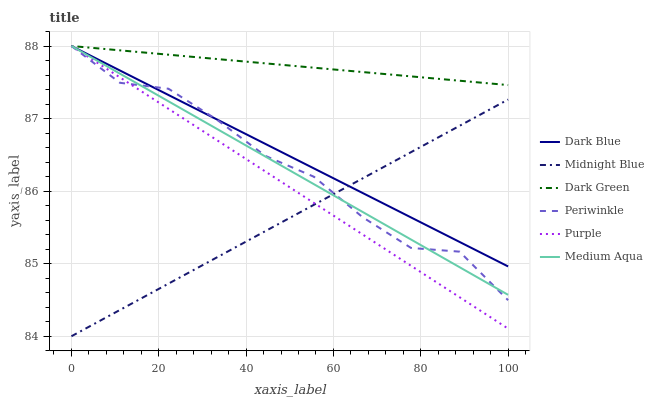Does Midnight Blue have the minimum area under the curve?
Answer yes or no. Yes. Does Dark Green have the maximum area under the curve?
Answer yes or no. Yes. Does Purple have the minimum area under the curve?
Answer yes or no. No. Does Purple have the maximum area under the curve?
Answer yes or no. No. Is Purple the smoothest?
Answer yes or no. Yes. Is Periwinkle the roughest?
Answer yes or no. Yes. Is Dark Blue the smoothest?
Answer yes or no. No. Is Dark Blue the roughest?
Answer yes or no. No. Does Midnight Blue have the lowest value?
Answer yes or no. Yes. Does Purple have the lowest value?
Answer yes or no. No. Does Dark Green have the highest value?
Answer yes or no. Yes. Is Midnight Blue less than Dark Green?
Answer yes or no. Yes. Is Dark Green greater than Midnight Blue?
Answer yes or no. Yes. Does Purple intersect Midnight Blue?
Answer yes or no. Yes. Is Purple less than Midnight Blue?
Answer yes or no. No. Is Purple greater than Midnight Blue?
Answer yes or no. No. Does Midnight Blue intersect Dark Green?
Answer yes or no. No. 